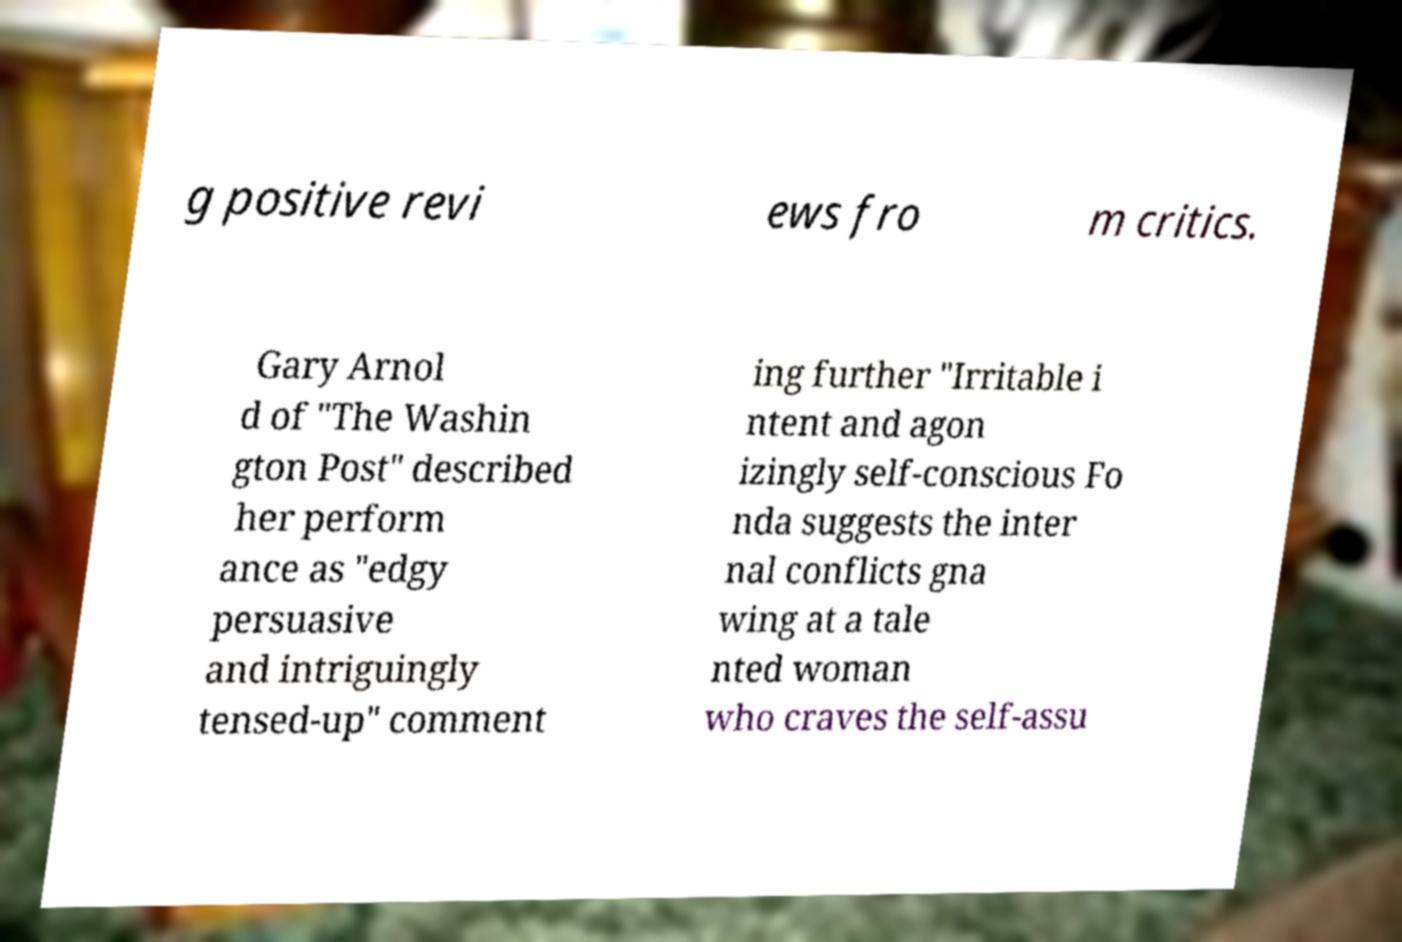Please identify and transcribe the text found in this image. g positive revi ews fro m critics. Gary Arnol d of "The Washin gton Post" described her perform ance as "edgy persuasive and intriguingly tensed-up" comment ing further "Irritable i ntent and agon izingly self-conscious Fo nda suggests the inter nal conflicts gna wing at a tale nted woman who craves the self-assu 